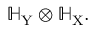Convert formula to latex. <formula><loc_0><loc_0><loc_500><loc_500>\mathbb { H } _ { Y } \otimes \mathbb { H } _ { X } .</formula> 